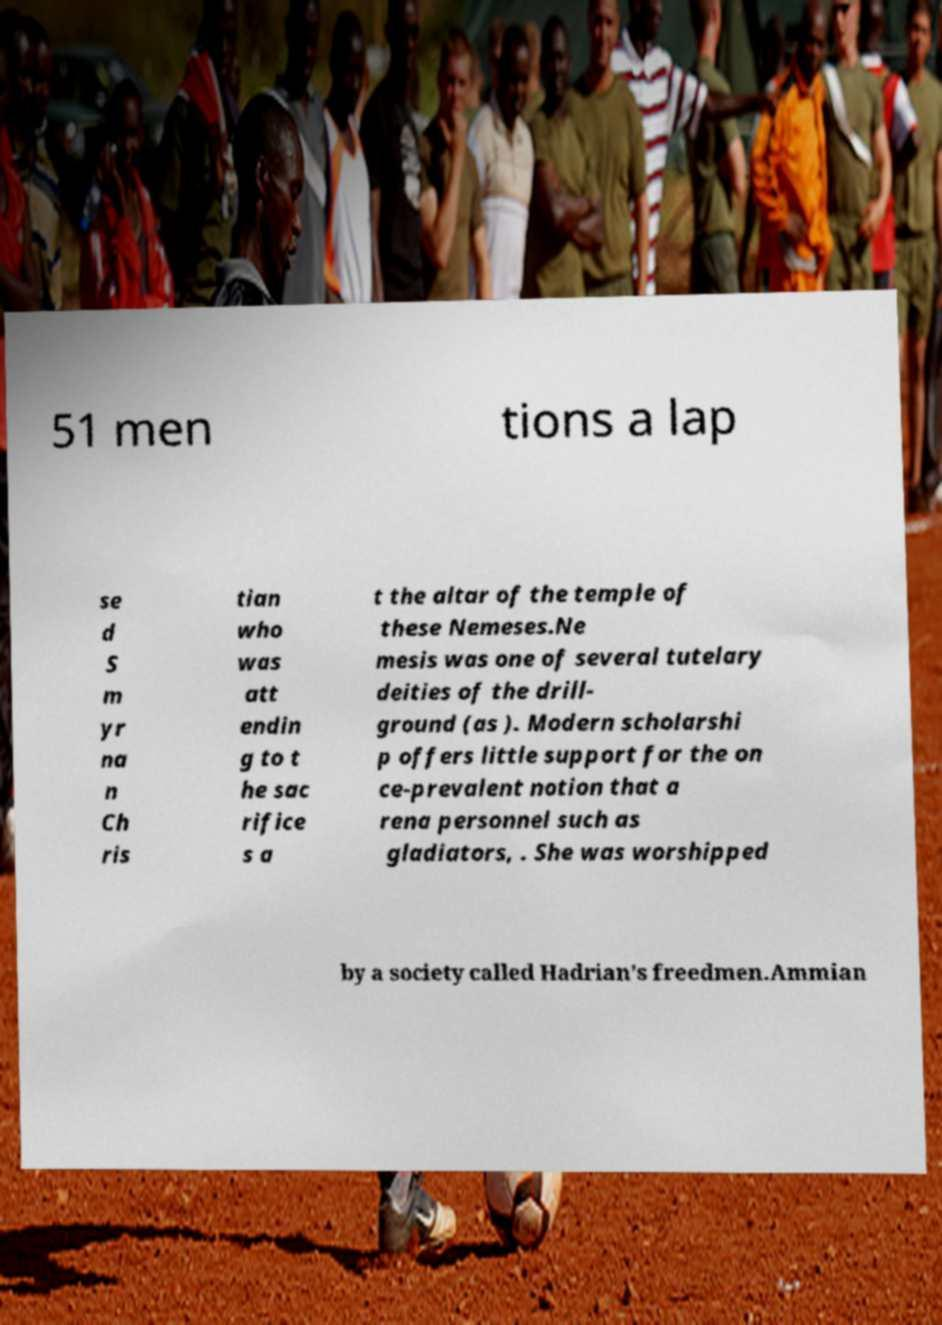Can you accurately transcribe the text from the provided image for me? 51 men tions a lap se d S m yr na n Ch ris tian who was att endin g to t he sac rifice s a t the altar of the temple of these Nemeses.Ne mesis was one of several tutelary deities of the drill- ground (as ). Modern scholarshi p offers little support for the on ce-prevalent notion that a rena personnel such as gladiators, . She was worshipped by a society called Hadrian's freedmen.Ammian 